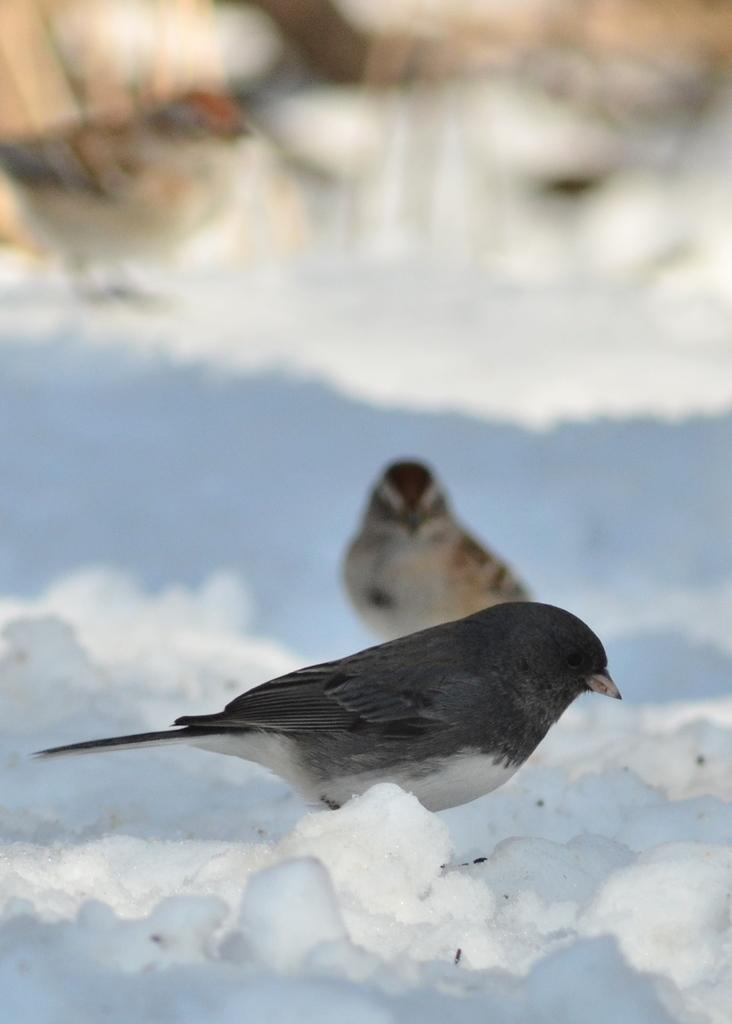What type of animals can be seen in the image? Birds can be seen in the image. What is the unusual condition of the birds in the image? The birds are in ice. What type of collar can be seen on the birds in the image? There is no collar present on the birds in the image. What type of bushes are visible in the image? There are no bushes visible in the image, as it only features birds in ice. 